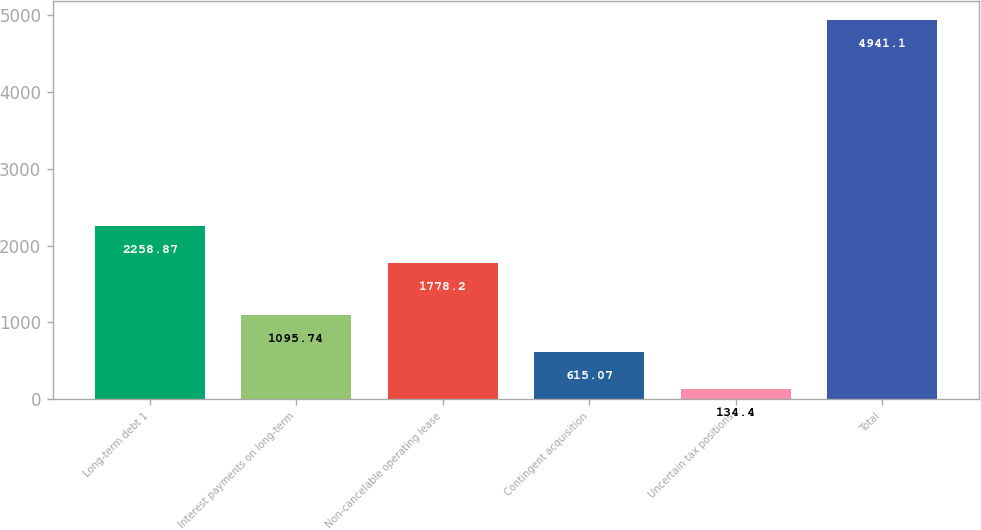<chart> <loc_0><loc_0><loc_500><loc_500><bar_chart><fcel>Long-term debt 1<fcel>Interest payments on long-term<fcel>Non-cancelable operating lease<fcel>Contingent acquisition<fcel>Uncertain tax positions<fcel>Total<nl><fcel>2258.87<fcel>1095.74<fcel>1778.2<fcel>615.07<fcel>134.4<fcel>4941.1<nl></chart> 